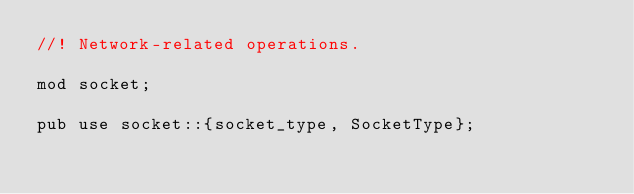<code> <loc_0><loc_0><loc_500><loc_500><_Rust_>//! Network-related operations.

mod socket;

pub use socket::{socket_type, SocketType};
</code> 